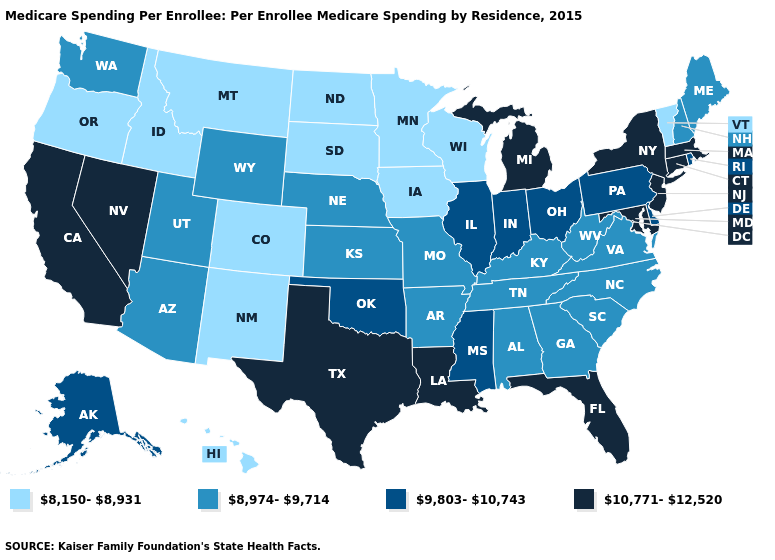Name the states that have a value in the range 10,771-12,520?
Answer briefly. California, Connecticut, Florida, Louisiana, Maryland, Massachusetts, Michigan, Nevada, New Jersey, New York, Texas. How many symbols are there in the legend?
Concise answer only. 4. Name the states that have a value in the range 9,803-10,743?
Keep it brief. Alaska, Delaware, Illinois, Indiana, Mississippi, Ohio, Oklahoma, Pennsylvania, Rhode Island. Name the states that have a value in the range 8,150-8,931?
Keep it brief. Colorado, Hawaii, Idaho, Iowa, Minnesota, Montana, New Mexico, North Dakota, Oregon, South Dakota, Vermont, Wisconsin. What is the value of South Carolina?
Quick response, please. 8,974-9,714. Which states have the highest value in the USA?
Write a very short answer. California, Connecticut, Florida, Louisiana, Maryland, Massachusetts, Michigan, Nevada, New Jersey, New York, Texas. What is the lowest value in states that border New York?
Answer briefly. 8,150-8,931. What is the value of Maryland?
Write a very short answer. 10,771-12,520. Among the states that border Ohio , which have the lowest value?
Be succinct. Kentucky, West Virginia. Among the states that border Texas , which have the lowest value?
Quick response, please. New Mexico. Name the states that have a value in the range 8,150-8,931?
Give a very brief answer. Colorado, Hawaii, Idaho, Iowa, Minnesota, Montana, New Mexico, North Dakota, Oregon, South Dakota, Vermont, Wisconsin. Among the states that border Utah , which have the highest value?
Short answer required. Nevada. What is the value of Mississippi?
Concise answer only. 9,803-10,743. What is the highest value in the West ?
Short answer required. 10,771-12,520. Is the legend a continuous bar?
Keep it brief. No. 